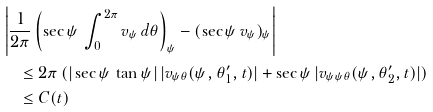<formula> <loc_0><loc_0><loc_500><loc_500>& \left | \frac { 1 } { 2 \pi } \left ( \sec \psi \, \int _ { 0 } ^ { 2 \pi } v _ { \psi } \, d \theta \right ) _ { \psi } - ( \sec \psi \, v _ { \psi } ) _ { \psi } \right | \\ & \quad \leq 2 \pi \, ( | \sec \psi \, \tan \psi | \, | v _ { \psi \theta } ( \psi , \theta _ { 1 } ^ { \prime } , t ) | + \sec \psi \, | v _ { \psi \psi \theta } ( \psi , \theta _ { 2 } ^ { \prime } , t ) | ) \\ & \quad \leq C ( t )</formula> 